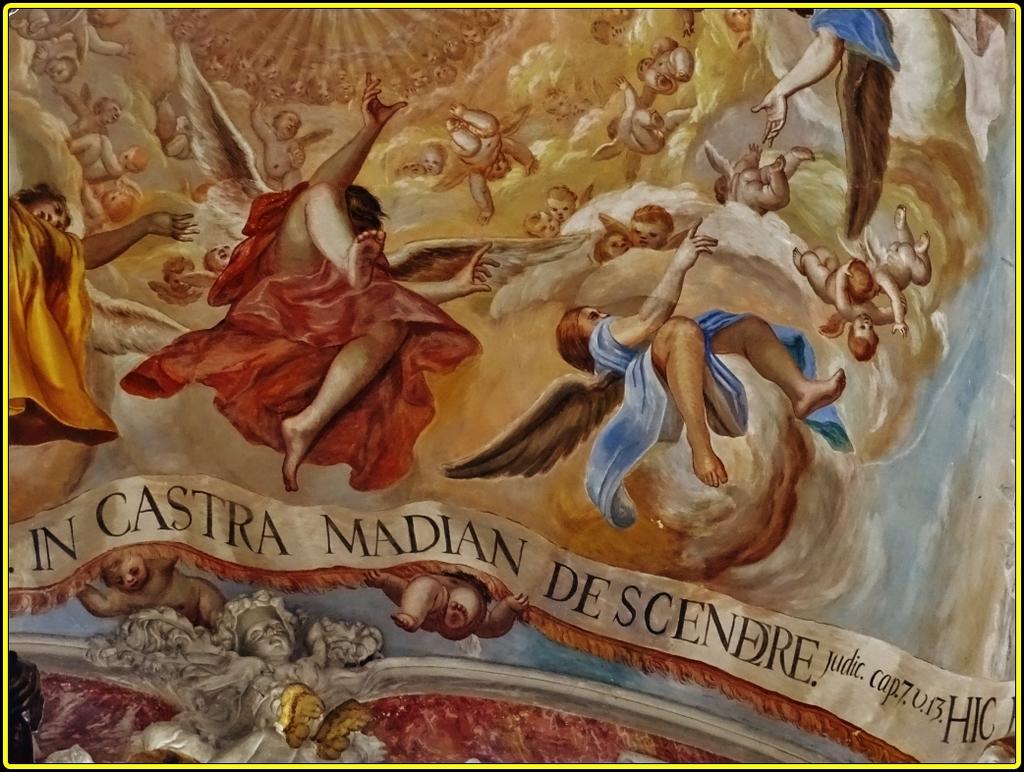Is the banner text in english?
Give a very brief answer. No. 